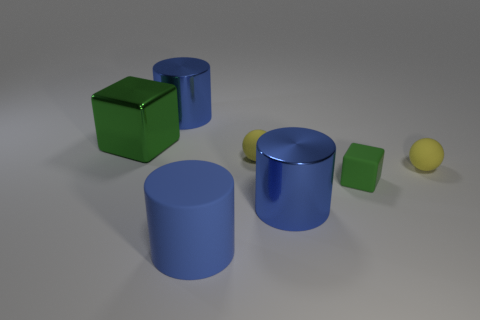There is a metallic cylinder that is behind the metal cube; is its size the same as the tiny green matte thing?
Offer a very short reply. No. There is a object that is behind the big blue matte object and in front of the tiny cube; what is its color?
Your response must be concise. Blue. What number of things are big matte cylinders or big metal cylinders behind the small block?
Make the answer very short. 2. What material is the green block that is in front of the small ball left of the blue cylinder to the right of the blue rubber thing made of?
Offer a very short reply. Rubber. Is the color of the object that is behind the large block the same as the big matte cylinder?
Give a very brief answer. Yes. How many cyan objects are small blocks or small things?
Give a very brief answer. 0. How many other things are there of the same shape as the tiny green rubber thing?
Make the answer very short. 1. What is the material of the big thing that is to the right of the large green metallic object and behind the small matte cube?
Make the answer very short. Metal. The tiny object left of the green rubber thing is what color?
Provide a short and direct response. Yellow. Are there more big blue rubber things that are in front of the big metal cube than big brown objects?
Ensure brevity in your answer.  Yes. 